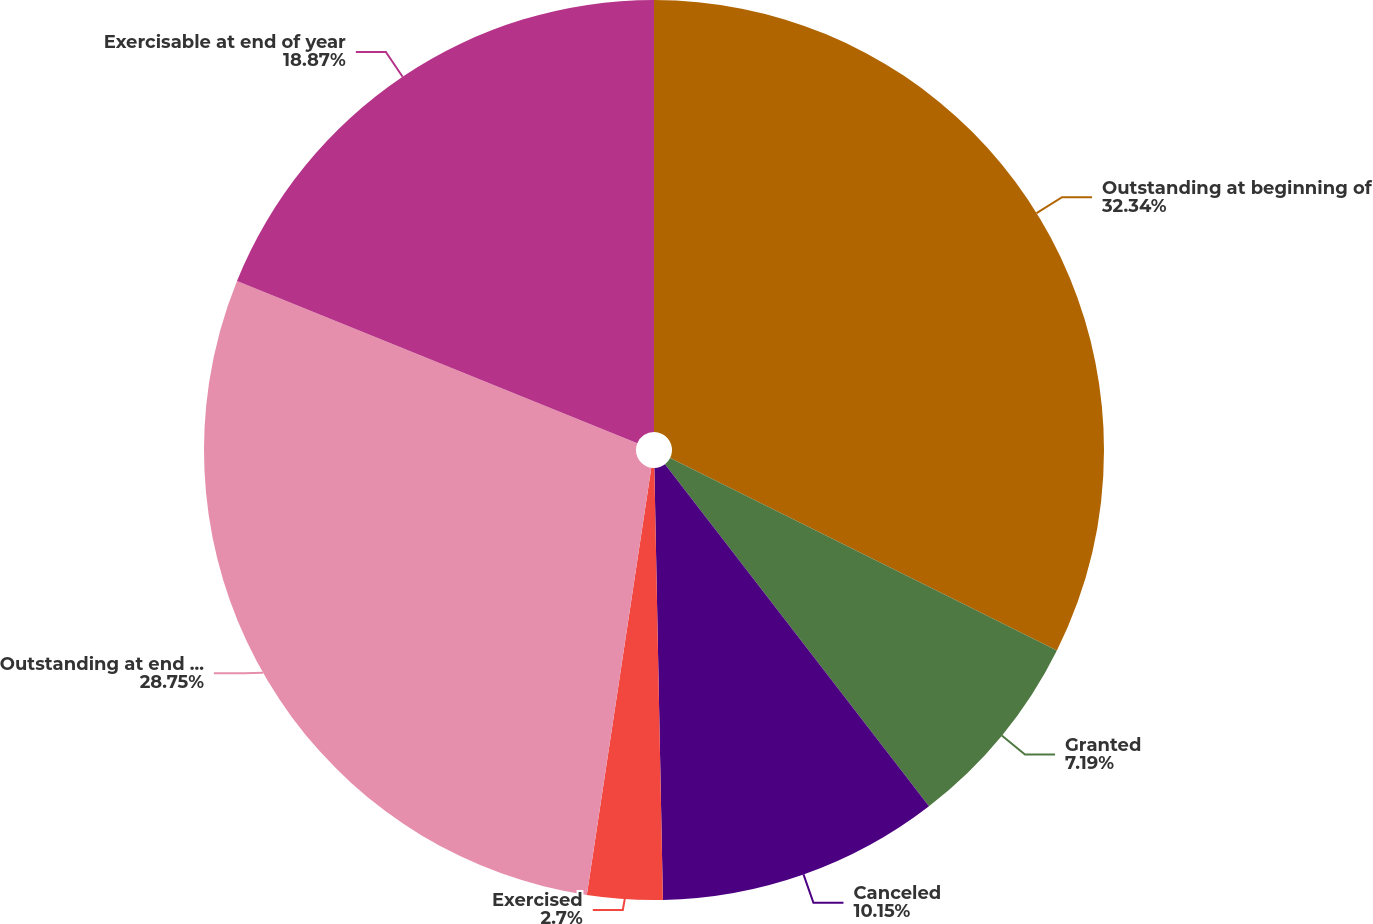Convert chart. <chart><loc_0><loc_0><loc_500><loc_500><pie_chart><fcel>Outstanding at beginning of<fcel>Granted<fcel>Canceled<fcel>Exercised<fcel>Outstanding at end of year<fcel>Exercisable at end of year<nl><fcel>32.35%<fcel>7.19%<fcel>10.15%<fcel>2.7%<fcel>28.75%<fcel>18.87%<nl></chart> 